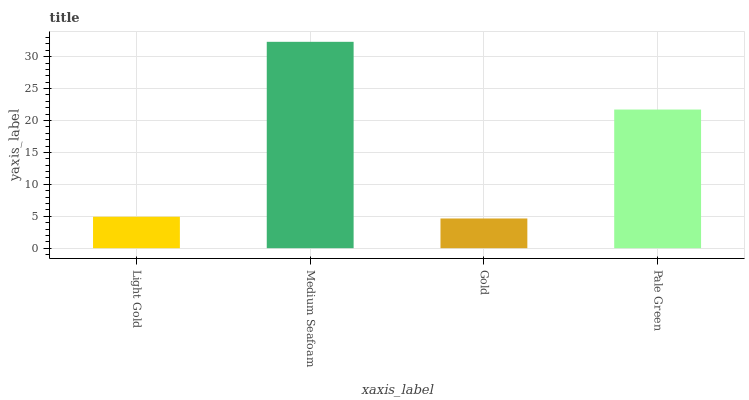Is Medium Seafoam the maximum?
Answer yes or no. Yes. Is Medium Seafoam the minimum?
Answer yes or no. No. Is Gold the maximum?
Answer yes or no. No. Is Medium Seafoam greater than Gold?
Answer yes or no. Yes. Is Gold less than Medium Seafoam?
Answer yes or no. Yes. Is Gold greater than Medium Seafoam?
Answer yes or no. No. Is Medium Seafoam less than Gold?
Answer yes or no. No. Is Pale Green the high median?
Answer yes or no. Yes. Is Light Gold the low median?
Answer yes or no. Yes. Is Light Gold the high median?
Answer yes or no. No. Is Medium Seafoam the low median?
Answer yes or no. No. 